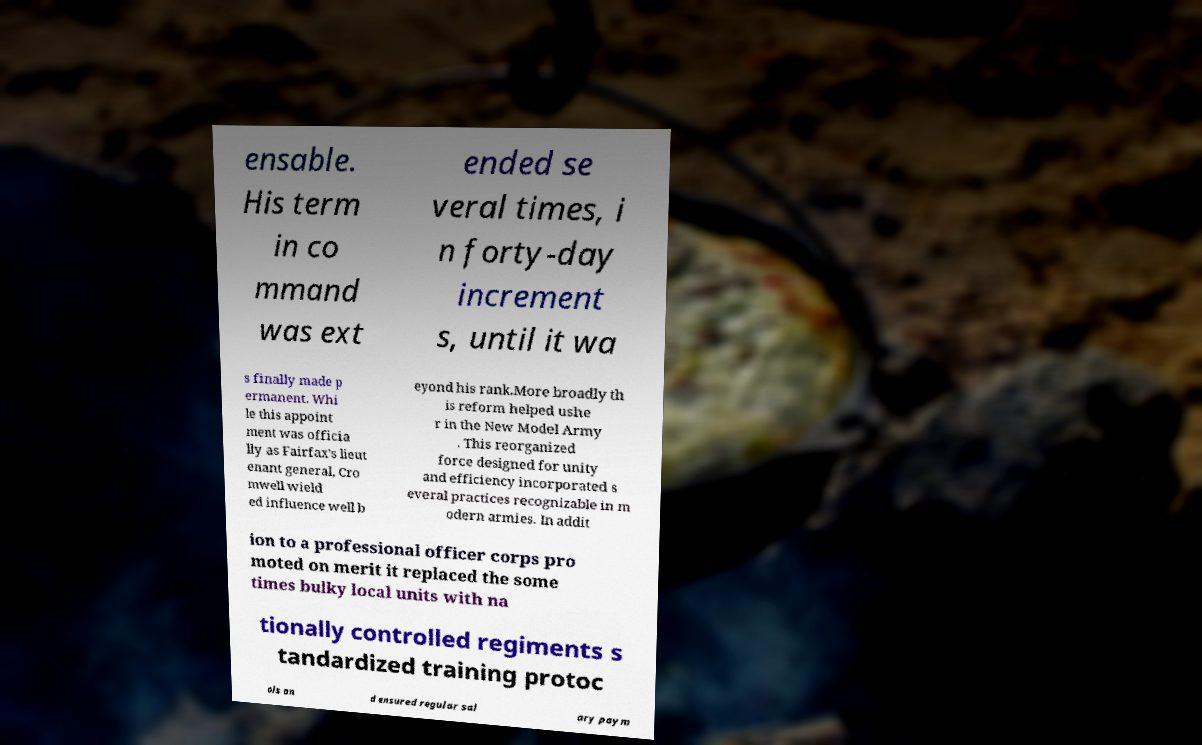Can you read and provide the text displayed in the image?This photo seems to have some interesting text. Can you extract and type it out for me? ensable. His term in co mmand was ext ended se veral times, i n forty-day increment s, until it wa s finally made p ermanent. Whi le this appoint ment was officia lly as Fairfax's lieut enant general, Cro mwell wield ed influence well b eyond his rank.More broadly th is reform helped ushe r in the New Model Army . This reorganized force designed for unity and efficiency incorporated s everal practices recognizable in m odern armies. In addit ion to a professional officer corps pro moted on merit it replaced the some times bulky local units with na tionally controlled regiments s tandardized training protoc ols an d ensured regular sal ary paym 